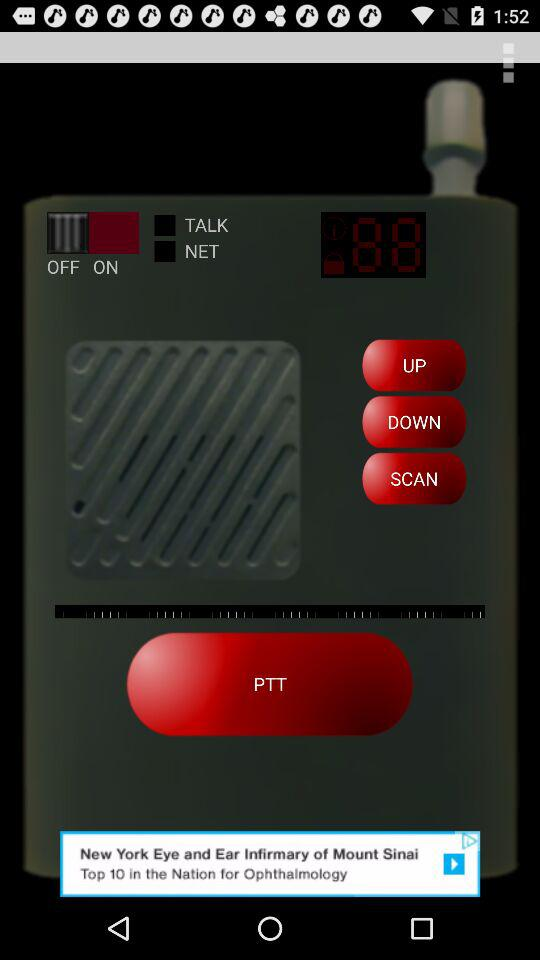What is the status of "TALK"? The status is "off". 